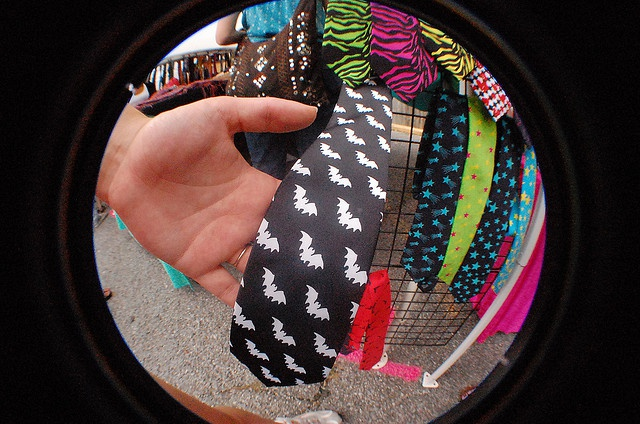Describe the objects in this image and their specific colors. I can see tie in black, gray, and lightgray tones, people in black, brown, and salmon tones, people in black, maroon, gray, and teal tones, tie in black, teal, and navy tones, and tie in black, teal, and navy tones in this image. 